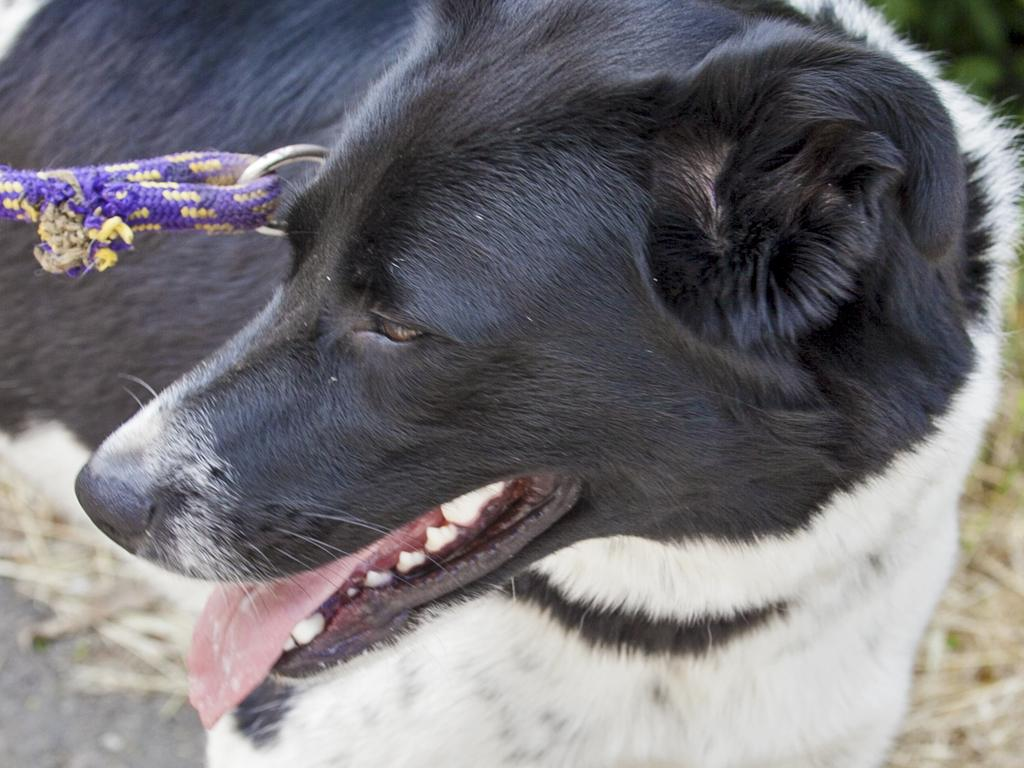What type of animal is in the picture? There is a dog in the picture. Can you describe the color of the dog? The dog is black and white in color. What is attached to the dog in the picture? There is a violet color belt tightened to the dog. What type of van can be seen parked near the plantation in the image? There is no van or plantation present in the image; it features a dog with a violet color belt. 